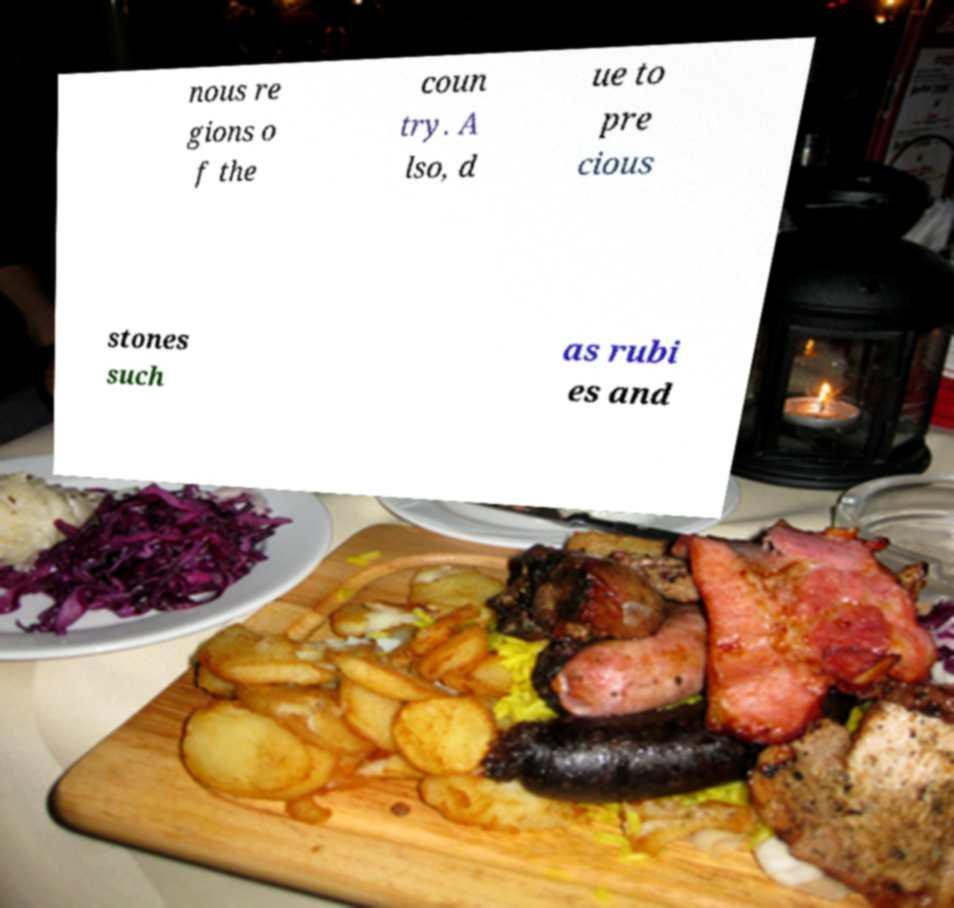Can you accurately transcribe the text from the provided image for me? nous re gions o f the coun try. A lso, d ue to pre cious stones such as rubi es and 